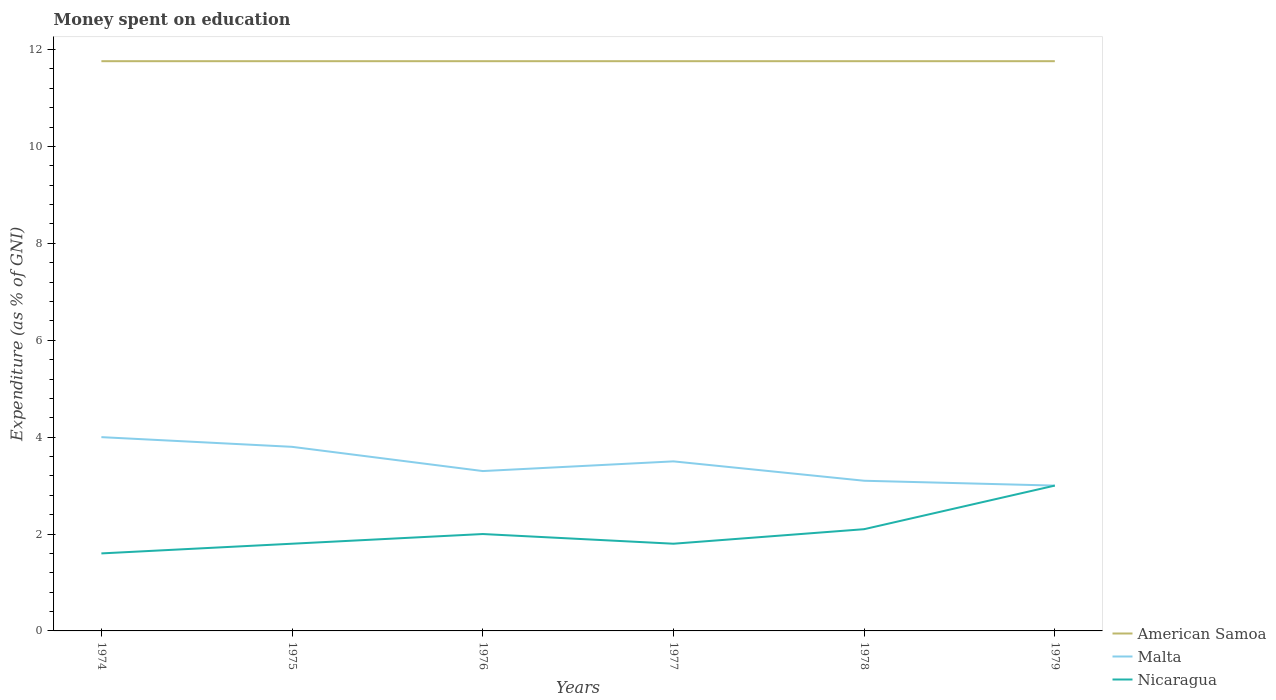Does the line corresponding to American Samoa intersect with the line corresponding to Malta?
Your response must be concise. No. Is the number of lines equal to the number of legend labels?
Make the answer very short. Yes. Across all years, what is the maximum amount of money spent on education in American Samoa?
Offer a very short reply. 11.76. In which year was the amount of money spent on education in Nicaragua maximum?
Offer a terse response. 1974. What is the total amount of money spent on education in Nicaragua in the graph?
Provide a succinct answer. 0.2. What is the difference between the highest and the second highest amount of money spent on education in Nicaragua?
Keep it short and to the point. 1.4. How many years are there in the graph?
Your answer should be compact. 6. Where does the legend appear in the graph?
Your response must be concise. Bottom right. How are the legend labels stacked?
Your answer should be compact. Vertical. What is the title of the graph?
Keep it short and to the point. Money spent on education. What is the label or title of the X-axis?
Provide a succinct answer. Years. What is the label or title of the Y-axis?
Give a very brief answer. Expenditure (as % of GNI). What is the Expenditure (as % of GNI) of American Samoa in 1974?
Keep it short and to the point. 11.76. What is the Expenditure (as % of GNI) of Nicaragua in 1974?
Provide a succinct answer. 1.6. What is the Expenditure (as % of GNI) of American Samoa in 1975?
Your answer should be compact. 11.76. What is the Expenditure (as % of GNI) in Malta in 1975?
Make the answer very short. 3.8. What is the Expenditure (as % of GNI) of Nicaragua in 1975?
Provide a succinct answer. 1.8. What is the Expenditure (as % of GNI) of American Samoa in 1976?
Offer a very short reply. 11.76. What is the Expenditure (as % of GNI) of Malta in 1976?
Your answer should be very brief. 3.3. What is the Expenditure (as % of GNI) of Nicaragua in 1976?
Make the answer very short. 2. What is the Expenditure (as % of GNI) in American Samoa in 1977?
Provide a succinct answer. 11.76. What is the Expenditure (as % of GNI) in Malta in 1977?
Your answer should be compact. 3.5. What is the Expenditure (as % of GNI) in Nicaragua in 1977?
Make the answer very short. 1.8. What is the Expenditure (as % of GNI) in American Samoa in 1978?
Make the answer very short. 11.76. What is the Expenditure (as % of GNI) in American Samoa in 1979?
Keep it short and to the point. 11.76. Across all years, what is the maximum Expenditure (as % of GNI) of American Samoa?
Offer a very short reply. 11.76. Across all years, what is the minimum Expenditure (as % of GNI) of American Samoa?
Provide a succinct answer. 11.76. Across all years, what is the minimum Expenditure (as % of GNI) in Malta?
Offer a terse response. 3. What is the total Expenditure (as % of GNI) in American Samoa in the graph?
Your answer should be compact. 70.56. What is the total Expenditure (as % of GNI) of Malta in the graph?
Your answer should be compact. 20.7. What is the difference between the Expenditure (as % of GNI) of American Samoa in 1974 and that in 1975?
Your answer should be very brief. 0. What is the difference between the Expenditure (as % of GNI) in Malta in 1974 and that in 1975?
Ensure brevity in your answer.  0.2. What is the difference between the Expenditure (as % of GNI) of Nicaragua in 1974 and that in 1975?
Your answer should be very brief. -0.2. What is the difference between the Expenditure (as % of GNI) of American Samoa in 1974 and that in 1976?
Provide a succinct answer. 0. What is the difference between the Expenditure (as % of GNI) of American Samoa in 1974 and that in 1977?
Make the answer very short. 0. What is the difference between the Expenditure (as % of GNI) of Malta in 1974 and that in 1977?
Provide a succinct answer. 0.5. What is the difference between the Expenditure (as % of GNI) in Nicaragua in 1974 and that in 1977?
Offer a very short reply. -0.2. What is the difference between the Expenditure (as % of GNI) in Nicaragua in 1974 and that in 1978?
Give a very brief answer. -0.5. What is the difference between the Expenditure (as % of GNI) of Malta in 1975 and that in 1976?
Your response must be concise. 0.5. What is the difference between the Expenditure (as % of GNI) in American Samoa in 1975 and that in 1977?
Ensure brevity in your answer.  0. What is the difference between the Expenditure (as % of GNI) in Nicaragua in 1975 and that in 1978?
Your answer should be very brief. -0.3. What is the difference between the Expenditure (as % of GNI) in American Samoa in 1975 and that in 1979?
Keep it short and to the point. 0. What is the difference between the Expenditure (as % of GNI) of Nicaragua in 1975 and that in 1979?
Your answer should be very brief. -1.2. What is the difference between the Expenditure (as % of GNI) of Nicaragua in 1976 and that in 1977?
Keep it short and to the point. 0.2. What is the difference between the Expenditure (as % of GNI) of American Samoa in 1976 and that in 1978?
Give a very brief answer. 0. What is the difference between the Expenditure (as % of GNI) in Malta in 1976 and that in 1978?
Your answer should be compact. 0.2. What is the difference between the Expenditure (as % of GNI) of American Samoa in 1976 and that in 1979?
Provide a succinct answer. 0. What is the difference between the Expenditure (as % of GNI) of Malta in 1976 and that in 1979?
Make the answer very short. 0.3. What is the difference between the Expenditure (as % of GNI) in American Samoa in 1977 and that in 1978?
Make the answer very short. 0. What is the difference between the Expenditure (as % of GNI) in Nicaragua in 1977 and that in 1978?
Give a very brief answer. -0.3. What is the difference between the Expenditure (as % of GNI) of Malta in 1977 and that in 1979?
Provide a short and direct response. 0.5. What is the difference between the Expenditure (as % of GNI) of Nicaragua in 1977 and that in 1979?
Your response must be concise. -1.2. What is the difference between the Expenditure (as % of GNI) of American Samoa in 1978 and that in 1979?
Your answer should be compact. 0. What is the difference between the Expenditure (as % of GNI) in Nicaragua in 1978 and that in 1979?
Your response must be concise. -0.9. What is the difference between the Expenditure (as % of GNI) of American Samoa in 1974 and the Expenditure (as % of GNI) of Malta in 1975?
Provide a short and direct response. 7.96. What is the difference between the Expenditure (as % of GNI) of American Samoa in 1974 and the Expenditure (as % of GNI) of Nicaragua in 1975?
Make the answer very short. 9.96. What is the difference between the Expenditure (as % of GNI) in American Samoa in 1974 and the Expenditure (as % of GNI) in Malta in 1976?
Your response must be concise. 8.46. What is the difference between the Expenditure (as % of GNI) in American Samoa in 1974 and the Expenditure (as % of GNI) in Nicaragua in 1976?
Give a very brief answer. 9.76. What is the difference between the Expenditure (as % of GNI) in American Samoa in 1974 and the Expenditure (as % of GNI) in Malta in 1977?
Provide a short and direct response. 8.26. What is the difference between the Expenditure (as % of GNI) of American Samoa in 1974 and the Expenditure (as % of GNI) of Nicaragua in 1977?
Make the answer very short. 9.96. What is the difference between the Expenditure (as % of GNI) of Malta in 1974 and the Expenditure (as % of GNI) of Nicaragua in 1977?
Keep it short and to the point. 2.2. What is the difference between the Expenditure (as % of GNI) of American Samoa in 1974 and the Expenditure (as % of GNI) of Malta in 1978?
Provide a succinct answer. 8.66. What is the difference between the Expenditure (as % of GNI) in American Samoa in 1974 and the Expenditure (as % of GNI) in Nicaragua in 1978?
Ensure brevity in your answer.  9.66. What is the difference between the Expenditure (as % of GNI) of American Samoa in 1974 and the Expenditure (as % of GNI) of Malta in 1979?
Offer a terse response. 8.76. What is the difference between the Expenditure (as % of GNI) of American Samoa in 1974 and the Expenditure (as % of GNI) of Nicaragua in 1979?
Your answer should be very brief. 8.76. What is the difference between the Expenditure (as % of GNI) of Malta in 1974 and the Expenditure (as % of GNI) of Nicaragua in 1979?
Make the answer very short. 1. What is the difference between the Expenditure (as % of GNI) of American Samoa in 1975 and the Expenditure (as % of GNI) of Malta in 1976?
Your response must be concise. 8.46. What is the difference between the Expenditure (as % of GNI) of American Samoa in 1975 and the Expenditure (as % of GNI) of Nicaragua in 1976?
Provide a short and direct response. 9.76. What is the difference between the Expenditure (as % of GNI) of Malta in 1975 and the Expenditure (as % of GNI) of Nicaragua in 1976?
Make the answer very short. 1.8. What is the difference between the Expenditure (as % of GNI) in American Samoa in 1975 and the Expenditure (as % of GNI) in Malta in 1977?
Make the answer very short. 8.26. What is the difference between the Expenditure (as % of GNI) of American Samoa in 1975 and the Expenditure (as % of GNI) of Nicaragua in 1977?
Offer a terse response. 9.96. What is the difference between the Expenditure (as % of GNI) in American Samoa in 1975 and the Expenditure (as % of GNI) in Malta in 1978?
Offer a terse response. 8.66. What is the difference between the Expenditure (as % of GNI) in American Samoa in 1975 and the Expenditure (as % of GNI) in Nicaragua in 1978?
Your answer should be very brief. 9.66. What is the difference between the Expenditure (as % of GNI) of Malta in 1975 and the Expenditure (as % of GNI) of Nicaragua in 1978?
Your answer should be very brief. 1.7. What is the difference between the Expenditure (as % of GNI) of American Samoa in 1975 and the Expenditure (as % of GNI) of Malta in 1979?
Give a very brief answer. 8.76. What is the difference between the Expenditure (as % of GNI) in American Samoa in 1975 and the Expenditure (as % of GNI) in Nicaragua in 1979?
Keep it short and to the point. 8.76. What is the difference between the Expenditure (as % of GNI) of Malta in 1975 and the Expenditure (as % of GNI) of Nicaragua in 1979?
Provide a succinct answer. 0.8. What is the difference between the Expenditure (as % of GNI) of American Samoa in 1976 and the Expenditure (as % of GNI) of Malta in 1977?
Offer a terse response. 8.26. What is the difference between the Expenditure (as % of GNI) in American Samoa in 1976 and the Expenditure (as % of GNI) in Nicaragua in 1977?
Keep it short and to the point. 9.96. What is the difference between the Expenditure (as % of GNI) in Malta in 1976 and the Expenditure (as % of GNI) in Nicaragua in 1977?
Offer a terse response. 1.5. What is the difference between the Expenditure (as % of GNI) in American Samoa in 1976 and the Expenditure (as % of GNI) in Malta in 1978?
Ensure brevity in your answer.  8.66. What is the difference between the Expenditure (as % of GNI) in American Samoa in 1976 and the Expenditure (as % of GNI) in Nicaragua in 1978?
Provide a succinct answer. 9.66. What is the difference between the Expenditure (as % of GNI) of Malta in 1976 and the Expenditure (as % of GNI) of Nicaragua in 1978?
Your answer should be compact. 1.2. What is the difference between the Expenditure (as % of GNI) in American Samoa in 1976 and the Expenditure (as % of GNI) in Malta in 1979?
Your answer should be compact. 8.76. What is the difference between the Expenditure (as % of GNI) of American Samoa in 1976 and the Expenditure (as % of GNI) of Nicaragua in 1979?
Offer a terse response. 8.76. What is the difference between the Expenditure (as % of GNI) in American Samoa in 1977 and the Expenditure (as % of GNI) in Malta in 1978?
Give a very brief answer. 8.66. What is the difference between the Expenditure (as % of GNI) in American Samoa in 1977 and the Expenditure (as % of GNI) in Nicaragua in 1978?
Make the answer very short. 9.66. What is the difference between the Expenditure (as % of GNI) of Malta in 1977 and the Expenditure (as % of GNI) of Nicaragua in 1978?
Make the answer very short. 1.4. What is the difference between the Expenditure (as % of GNI) of American Samoa in 1977 and the Expenditure (as % of GNI) of Malta in 1979?
Ensure brevity in your answer.  8.76. What is the difference between the Expenditure (as % of GNI) in American Samoa in 1977 and the Expenditure (as % of GNI) in Nicaragua in 1979?
Make the answer very short. 8.76. What is the difference between the Expenditure (as % of GNI) of Malta in 1977 and the Expenditure (as % of GNI) of Nicaragua in 1979?
Ensure brevity in your answer.  0.5. What is the difference between the Expenditure (as % of GNI) of American Samoa in 1978 and the Expenditure (as % of GNI) of Malta in 1979?
Your answer should be compact. 8.76. What is the difference between the Expenditure (as % of GNI) in American Samoa in 1978 and the Expenditure (as % of GNI) in Nicaragua in 1979?
Your response must be concise. 8.76. What is the average Expenditure (as % of GNI) in American Samoa per year?
Offer a very short reply. 11.76. What is the average Expenditure (as % of GNI) in Malta per year?
Provide a succinct answer. 3.45. What is the average Expenditure (as % of GNI) of Nicaragua per year?
Ensure brevity in your answer.  2.05. In the year 1974, what is the difference between the Expenditure (as % of GNI) in American Samoa and Expenditure (as % of GNI) in Malta?
Ensure brevity in your answer.  7.76. In the year 1974, what is the difference between the Expenditure (as % of GNI) of American Samoa and Expenditure (as % of GNI) of Nicaragua?
Your response must be concise. 10.16. In the year 1974, what is the difference between the Expenditure (as % of GNI) of Malta and Expenditure (as % of GNI) of Nicaragua?
Offer a terse response. 2.4. In the year 1975, what is the difference between the Expenditure (as % of GNI) of American Samoa and Expenditure (as % of GNI) of Malta?
Offer a terse response. 7.96. In the year 1975, what is the difference between the Expenditure (as % of GNI) in American Samoa and Expenditure (as % of GNI) in Nicaragua?
Your answer should be very brief. 9.96. In the year 1976, what is the difference between the Expenditure (as % of GNI) in American Samoa and Expenditure (as % of GNI) in Malta?
Your answer should be compact. 8.46. In the year 1976, what is the difference between the Expenditure (as % of GNI) in American Samoa and Expenditure (as % of GNI) in Nicaragua?
Give a very brief answer. 9.76. In the year 1977, what is the difference between the Expenditure (as % of GNI) in American Samoa and Expenditure (as % of GNI) in Malta?
Provide a short and direct response. 8.26. In the year 1977, what is the difference between the Expenditure (as % of GNI) in American Samoa and Expenditure (as % of GNI) in Nicaragua?
Your response must be concise. 9.96. In the year 1978, what is the difference between the Expenditure (as % of GNI) of American Samoa and Expenditure (as % of GNI) of Malta?
Provide a succinct answer. 8.66. In the year 1978, what is the difference between the Expenditure (as % of GNI) in American Samoa and Expenditure (as % of GNI) in Nicaragua?
Provide a short and direct response. 9.66. In the year 1979, what is the difference between the Expenditure (as % of GNI) in American Samoa and Expenditure (as % of GNI) in Malta?
Ensure brevity in your answer.  8.76. In the year 1979, what is the difference between the Expenditure (as % of GNI) of American Samoa and Expenditure (as % of GNI) of Nicaragua?
Offer a terse response. 8.76. In the year 1979, what is the difference between the Expenditure (as % of GNI) in Malta and Expenditure (as % of GNI) in Nicaragua?
Offer a very short reply. 0. What is the ratio of the Expenditure (as % of GNI) of American Samoa in 1974 to that in 1975?
Make the answer very short. 1. What is the ratio of the Expenditure (as % of GNI) in Malta in 1974 to that in 1975?
Make the answer very short. 1.05. What is the ratio of the Expenditure (as % of GNI) in American Samoa in 1974 to that in 1976?
Make the answer very short. 1. What is the ratio of the Expenditure (as % of GNI) of Malta in 1974 to that in 1976?
Offer a terse response. 1.21. What is the ratio of the Expenditure (as % of GNI) of American Samoa in 1974 to that in 1977?
Your response must be concise. 1. What is the ratio of the Expenditure (as % of GNI) in Malta in 1974 to that in 1978?
Offer a terse response. 1.29. What is the ratio of the Expenditure (as % of GNI) in Nicaragua in 1974 to that in 1978?
Your answer should be compact. 0.76. What is the ratio of the Expenditure (as % of GNI) in Malta in 1974 to that in 1979?
Your response must be concise. 1.33. What is the ratio of the Expenditure (as % of GNI) of Nicaragua in 1974 to that in 1979?
Your answer should be compact. 0.53. What is the ratio of the Expenditure (as % of GNI) of American Samoa in 1975 to that in 1976?
Ensure brevity in your answer.  1. What is the ratio of the Expenditure (as % of GNI) in Malta in 1975 to that in 1976?
Your response must be concise. 1.15. What is the ratio of the Expenditure (as % of GNI) in Malta in 1975 to that in 1977?
Offer a very short reply. 1.09. What is the ratio of the Expenditure (as % of GNI) in Nicaragua in 1975 to that in 1977?
Your response must be concise. 1. What is the ratio of the Expenditure (as % of GNI) of Malta in 1975 to that in 1978?
Your answer should be compact. 1.23. What is the ratio of the Expenditure (as % of GNI) in American Samoa in 1975 to that in 1979?
Your answer should be very brief. 1. What is the ratio of the Expenditure (as % of GNI) of Malta in 1975 to that in 1979?
Offer a terse response. 1.27. What is the ratio of the Expenditure (as % of GNI) of Nicaragua in 1975 to that in 1979?
Offer a terse response. 0.6. What is the ratio of the Expenditure (as % of GNI) of Malta in 1976 to that in 1977?
Give a very brief answer. 0.94. What is the ratio of the Expenditure (as % of GNI) of American Samoa in 1976 to that in 1978?
Provide a short and direct response. 1. What is the ratio of the Expenditure (as % of GNI) of Malta in 1976 to that in 1978?
Ensure brevity in your answer.  1.06. What is the ratio of the Expenditure (as % of GNI) of Nicaragua in 1976 to that in 1978?
Your answer should be compact. 0.95. What is the ratio of the Expenditure (as % of GNI) of American Samoa in 1976 to that in 1979?
Provide a succinct answer. 1. What is the ratio of the Expenditure (as % of GNI) in Nicaragua in 1976 to that in 1979?
Your answer should be very brief. 0.67. What is the ratio of the Expenditure (as % of GNI) in American Samoa in 1977 to that in 1978?
Provide a short and direct response. 1. What is the ratio of the Expenditure (as % of GNI) in Malta in 1977 to that in 1978?
Ensure brevity in your answer.  1.13. What is the ratio of the Expenditure (as % of GNI) of Nicaragua in 1977 to that in 1978?
Ensure brevity in your answer.  0.86. What is the ratio of the Expenditure (as % of GNI) in Malta in 1977 to that in 1979?
Make the answer very short. 1.17. What is the ratio of the Expenditure (as % of GNI) of Nicaragua in 1977 to that in 1979?
Offer a very short reply. 0.6. What is the difference between the highest and the second highest Expenditure (as % of GNI) in American Samoa?
Make the answer very short. 0. What is the difference between the highest and the lowest Expenditure (as % of GNI) in Malta?
Your answer should be compact. 1. What is the difference between the highest and the lowest Expenditure (as % of GNI) of Nicaragua?
Your answer should be very brief. 1.4. 